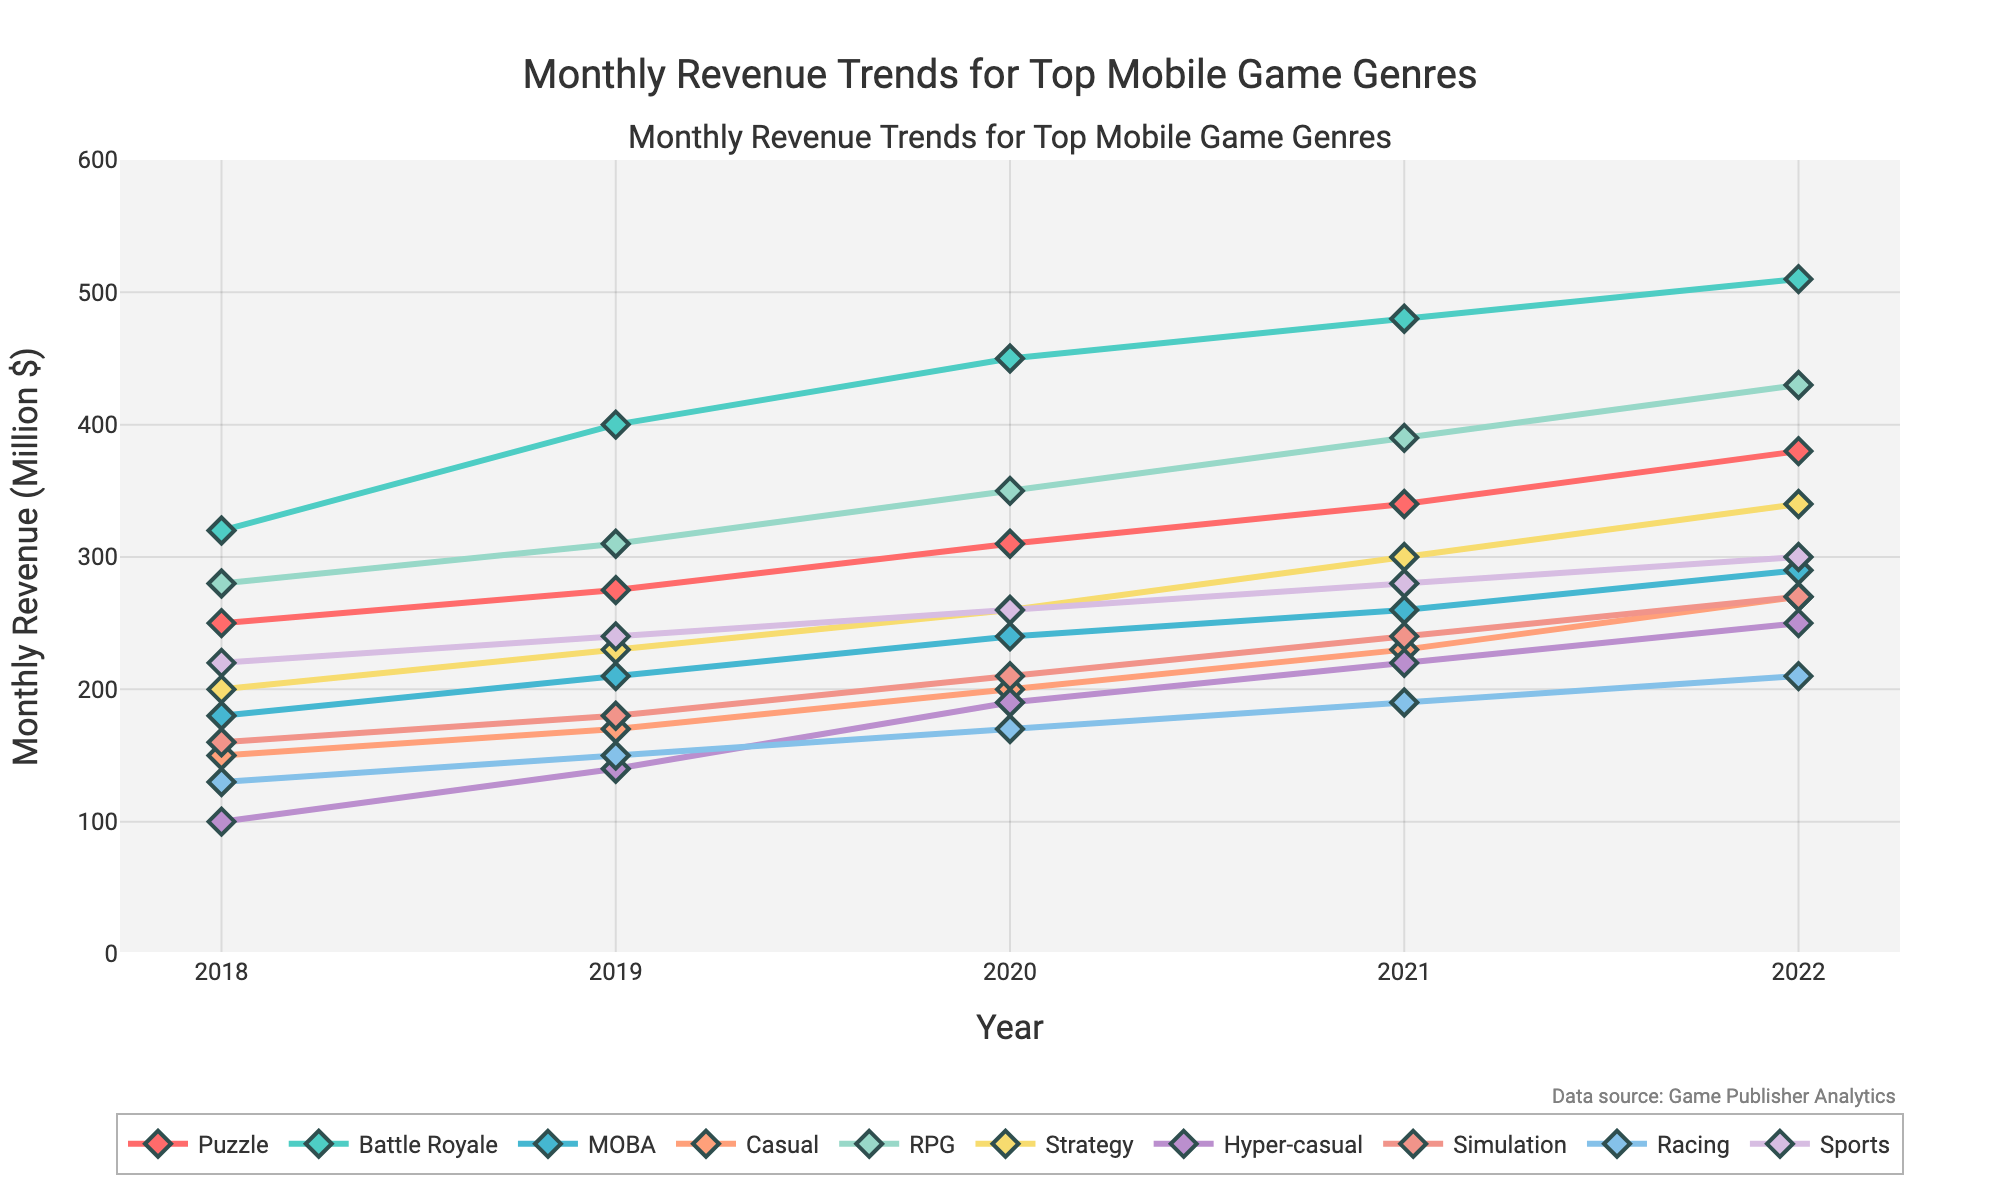What genre experienced the highest revenue in 2022? By looking at the end of each line representing 2022, the line for 'Battle Royale' is the highest.
Answer: Battle Royale Which genre has the lowest revenue in 2018? By checking the start of each line representing 2018, the 'Hyper-casual' genre shows the lowest point.
Answer: Hyper-casual What is the difference in revenue between RPG and Simulation genres in 2020? In 2020, RPG has a revenue of 350 million, and Simulation has 210 million. The difference is 350 - 210 = 140 million.
Answer: 140 million Which genre showed the most consistent growth over the years? By visually examining the slope of each line, 'Battle Royale' shows a steady, upward-sloping line without any significant dips.
Answer: Battle Royale In which year did the Puzzle genre surpass the 300 million revenue mark? The Puzzle genre's line crosses the 300 million mark between 2019 and 2020. Therefore, in 2020, it surpassed 300 million.
Answer: 2020 Has the Sports genre's revenue increased or decreased from 2018 to 2022? By observing the Sports line from 2018 (220 million) to 2022 (300 million), it's clear that the revenue has increased.
Answer: Increased Which three genres had the highest revenue growth from 2018 to 2022? By calculating the difference from 2018 to 2022 for each genre, 'Battle Royale' (510 - 320 = 190 million), 'RPG' (430 - 280 = 150 million), and 'Puzzle' (380 - 250 = 130 million) show the highest growth.
Answer: Battle Royale, RPG, Puzzle In which year did the Strategy genre reach a revenue of 300 million? By following the Strategy genre’s line, it reaches 300 million in 2022.
Answer: 2022 What is the average revenue of the Casual genre over the 5 years? Sum the revenue values for Casual (150 + 170 + 200 + 230 + 270) = 1020 and divide by 5 (years), 1020 / 5 = 204 million.
Answer: 204 million Compare the revenue trend of MOBA and Racing genres. Do both show an upward trend? Visually, both the MOBA and Racing genre lines slope upwards from 2018 to 2022.
Answer: Yes Which genre had a revenue closest to 200 million in 2022? In 2022, the closest genre to 200 million is Racing with 210 million.
Answer: Racing 